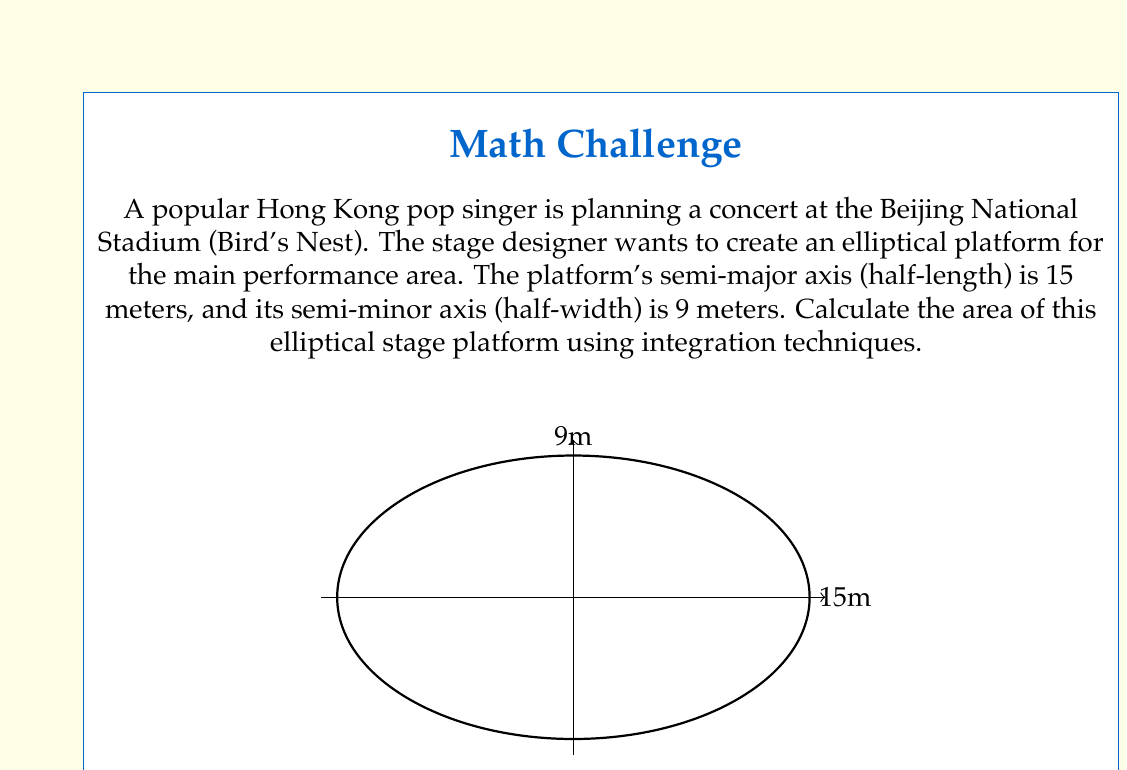Give your solution to this math problem. Let's approach this step-by-step:

1) The equation of an ellipse centered at the origin is given by:

   $$\frac{x^2}{a^2} + \frac{y^2}{b^2} = 1$$

   where $a$ is the semi-major axis and $b$ is the semi-minor axis.

2) In this case, $a = 15$ and $b = 9$. So our ellipse equation is:

   $$\frac{x^2}{15^2} + \frac{y^2}{9^2} = 1$$

3) To find the area using integration, we can use the formula:

   $$\text{Area} = 4 \int_0^a y \, dx$$

   where $y$ is expressed in terms of $x$.

4) From our ellipse equation, we can solve for $y$:

   $$y = \pm 9 \sqrt{1 - \frac{x^2}{15^2}}$$

5) Now we can set up our integral:

   $$\text{Area} = 4 \int_0^{15} 9 \sqrt{1 - \frac{x^2}{15^2}} \, dx$$

6) This is a standard elliptic integral. The result is:

   $$\text{Area} = 4 \cdot 9 \cdot 15 \cdot \frac{\pi}{4} = 135\pi$$

7) Therefore, the area of the elliptical stage platform is $135\pi$ square meters.

Note: We could also use the formula $\text{Area} = \pi ab$, but the question specifically asks for integration techniques.
Answer: The area of the elliptical stage platform is $135\pi \approx 423.9$ square meters. 